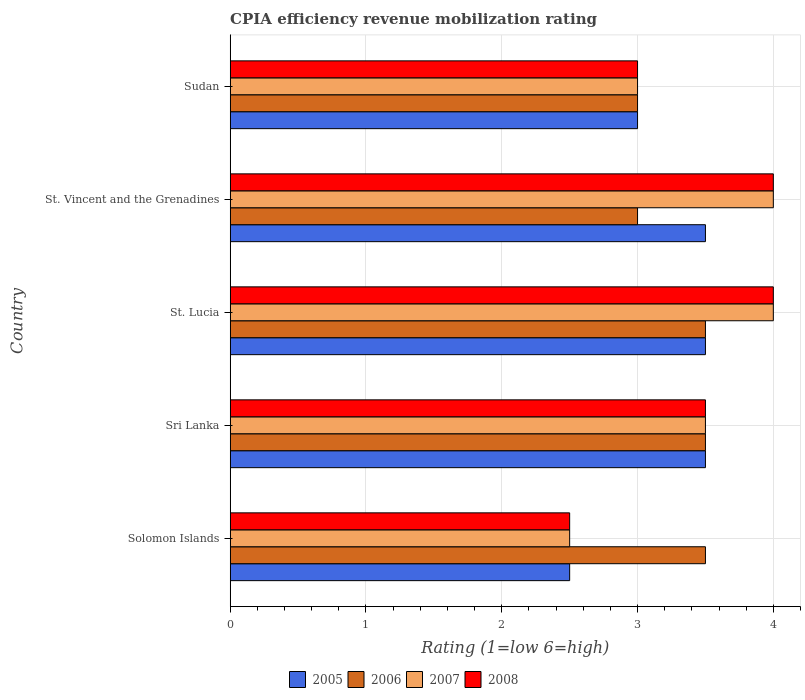How many groups of bars are there?
Provide a short and direct response. 5. Are the number of bars per tick equal to the number of legend labels?
Offer a terse response. Yes. Are the number of bars on each tick of the Y-axis equal?
Your response must be concise. Yes. How many bars are there on the 1st tick from the top?
Offer a terse response. 4. What is the label of the 3rd group of bars from the top?
Your answer should be compact. St. Lucia. In how many cases, is the number of bars for a given country not equal to the number of legend labels?
Keep it short and to the point. 0. Across all countries, what is the maximum CPIA rating in 2006?
Make the answer very short. 3.5. Across all countries, what is the minimum CPIA rating in 2007?
Offer a very short reply. 2.5. In which country was the CPIA rating in 2007 maximum?
Your answer should be compact. St. Lucia. In which country was the CPIA rating in 2007 minimum?
Your answer should be very brief. Solomon Islands. What is the total CPIA rating in 2007 in the graph?
Keep it short and to the point. 17. What is the difference between the CPIA rating in 2005 in Solomon Islands and that in St. Lucia?
Your answer should be compact. -1. What is the average CPIA rating in 2006 per country?
Your answer should be very brief. 3.3. What is the difference between the CPIA rating in 2007 and CPIA rating in 2006 in Solomon Islands?
Provide a succinct answer. -1. In how many countries, is the CPIA rating in 2008 greater than 1.2 ?
Ensure brevity in your answer.  5. What is the ratio of the CPIA rating in 2007 in St. Lucia to that in Sudan?
Give a very brief answer. 1.33. Is the difference between the CPIA rating in 2007 in Sri Lanka and St. Lucia greater than the difference between the CPIA rating in 2006 in Sri Lanka and St. Lucia?
Keep it short and to the point. No. What does the 1st bar from the top in Sri Lanka represents?
Offer a very short reply. 2008. Does the graph contain any zero values?
Give a very brief answer. No. How are the legend labels stacked?
Provide a short and direct response. Horizontal. What is the title of the graph?
Give a very brief answer. CPIA efficiency revenue mobilization rating. What is the label or title of the Y-axis?
Ensure brevity in your answer.  Country. What is the Rating (1=low 6=high) of 2005 in Solomon Islands?
Provide a succinct answer. 2.5. What is the Rating (1=low 6=high) of 2007 in Solomon Islands?
Make the answer very short. 2.5. What is the Rating (1=low 6=high) of 2005 in Sri Lanka?
Ensure brevity in your answer.  3.5. What is the Rating (1=low 6=high) of 2007 in Sri Lanka?
Offer a very short reply. 3.5. What is the Rating (1=low 6=high) of 2008 in Sri Lanka?
Ensure brevity in your answer.  3.5. What is the Rating (1=low 6=high) in 2005 in St. Vincent and the Grenadines?
Offer a terse response. 3.5. What is the Rating (1=low 6=high) of 2006 in St. Vincent and the Grenadines?
Offer a terse response. 3. What is the Rating (1=low 6=high) of 2007 in St. Vincent and the Grenadines?
Make the answer very short. 4. What is the Rating (1=low 6=high) of 2007 in Sudan?
Offer a terse response. 3. What is the Rating (1=low 6=high) in 2008 in Sudan?
Offer a terse response. 3. Across all countries, what is the maximum Rating (1=low 6=high) in 2007?
Give a very brief answer. 4. Across all countries, what is the maximum Rating (1=low 6=high) of 2008?
Ensure brevity in your answer.  4. Across all countries, what is the minimum Rating (1=low 6=high) in 2006?
Keep it short and to the point. 3. What is the total Rating (1=low 6=high) of 2006 in the graph?
Offer a terse response. 16.5. What is the difference between the Rating (1=low 6=high) of 2006 in Solomon Islands and that in Sri Lanka?
Your answer should be very brief. 0. What is the difference between the Rating (1=low 6=high) in 2008 in Solomon Islands and that in Sri Lanka?
Give a very brief answer. -1. What is the difference between the Rating (1=low 6=high) of 2007 in Solomon Islands and that in St. Lucia?
Offer a terse response. -1.5. What is the difference between the Rating (1=low 6=high) of 2005 in Solomon Islands and that in St. Vincent and the Grenadines?
Offer a terse response. -1. What is the difference between the Rating (1=low 6=high) of 2006 in Solomon Islands and that in St. Vincent and the Grenadines?
Offer a terse response. 0.5. What is the difference between the Rating (1=low 6=high) in 2007 in Solomon Islands and that in St. Vincent and the Grenadines?
Your answer should be compact. -1.5. What is the difference between the Rating (1=low 6=high) of 2005 in Solomon Islands and that in Sudan?
Provide a short and direct response. -0.5. What is the difference between the Rating (1=low 6=high) in 2007 in Solomon Islands and that in Sudan?
Your response must be concise. -0.5. What is the difference between the Rating (1=low 6=high) in 2005 in Sri Lanka and that in St. Lucia?
Provide a succinct answer. 0. What is the difference between the Rating (1=low 6=high) in 2006 in Sri Lanka and that in St. Lucia?
Your answer should be compact. 0. What is the difference between the Rating (1=low 6=high) in 2007 in Sri Lanka and that in St. Lucia?
Provide a succinct answer. -0.5. What is the difference between the Rating (1=low 6=high) of 2005 in Sri Lanka and that in St. Vincent and the Grenadines?
Provide a short and direct response. 0. What is the difference between the Rating (1=low 6=high) in 2007 in Sri Lanka and that in St. Vincent and the Grenadines?
Provide a short and direct response. -0.5. What is the difference between the Rating (1=low 6=high) in 2008 in Sri Lanka and that in St. Vincent and the Grenadines?
Offer a terse response. -0.5. What is the difference between the Rating (1=low 6=high) in 2005 in Sri Lanka and that in Sudan?
Your answer should be very brief. 0.5. What is the difference between the Rating (1=low 6=high) of 2006 in Sri Lanka and that in Sudan?
Provide a succinct answer. 0.5. What is the difference between the Rating (1=low 6=high) in 2007 in Sri Lanka and that in Sudan?
Provide a succinct answer. 0.5. What is the difference between the Rating (1=low 6=high) of 2008 in Sri Lanka and that in Sudan?
Your answer should be compact. 0.5. What is the difference between the Rating (1=low 6=high) in 2005 in St. Lucia and that in St. Vincent and the Grenadines?
Your response must be concise. 0. What is the difference between the Rating (1=low 6=high) of 2008 in St. Lucia and that in St. Vincent and the Grenadines?
Provide a short and direct response. 0. What is the difference between the Rating (1=low 6=high) in 2005 in St. Vincent and the Grenadines and that in Sudan?
Offer a very short reply. 0.5. What is the difference between the Rating (1=low 6=high) of 2006 in St. Vincent and the Grenadines and that in Sudan?
Provide a succinct answer. 0. What is the difference between the Rating (1=low 6=high) in 2005 in Solomon Islands and the Rating (1=low 6=high) in 2006 in Sri Lanka?
Give a very brief answer. -1. What is the difference between the Rating (1=low 6=high) of 2006 in Solomon Islands and the Rating (1=low 6=high) of 2007 in Sri Lanka?
Your response must be concise. 0. What is the difference between the Rating (1=low 6=high) of 2007 in Solomon Islands and the Rating (1=low 6=high) of 2008 in Sri Lanka?
Your answer should be compact. -1. What is the difference between the Rating (1=low 6=high) of 2005 in Solomon Islands and the Rating (1=low 6=high) of 2006 in St. Lucia?
Provide a succinct answer. -1. What is the difference between the Rating (1=low 6=high) of 2005 in Solomon Islands and the Rating (1=low 6=high) of 2007 in St. Lucia?
Offer a very short reply. -1.5. What is the difference between the Rating (1=low 6=high) in 2005 in Solomon Islands and the Rating (1=low 6=high) in 2008 in St. Lucia?
Your answer should be compact. -1.5. What is the difference between the Rating (1=low 6=high) in 2006 in Solomon Islands and the Rating (1=low 6=high) in 2007 in St. Vincent and the Grenadines?
Provide a succinct answer. -0.5. What is the difference between the Rating (1=low 6=high) of 2006 in Solomon Islands and the Rating (1=low 6=high) of 2008 in St. Vincent and the Grenadines?
Your answer should be very brief. -0.5. What is the difference between the Rating (1=low 6=high) in 2006 in Sri Lanka and the Rating (1=low 6=high) in 2008 in St. Lucia?
Your answer should be very brief. -0.5. What is the difference between the Rating (1=low 6=high) of 2005 in Sri Lanka and the Rating (1=low 6=high) of 2008 in St. Vincent and the Grenadines?
Give a very brief answer. -0.5. What is the difference between the Rating (1=low 6=high) in 2006 in Sri Lanka and the Rating (1=low 6=high) in 2007 in Sudan?
Offer a terse response. 0.5. What is the difference between the Rating (1=low 6=high) in 2006 in Sri Lanka and the Rating (1=low 6=high) in 2008 in Sudan?
Provide a succinct answer. 0.5. What is the difference between the Rating (1=low 6=high) in 2007 in Sri Lanka and the Rating (1=low 6=high) in 2008 in Sudan?
Your answer should be very brief. 0.5. What is the difference between the Rating (1=low 6=high) in 2005 in St. Lucia and the Rating (1=low 6=high) in 2006 in St. Vincent and the Grenadines?
Give a very brief answer. 0.5. What is the difference between the Rating (1=low 6=high) of 2005 in St. Lucia and the Rating (1=low 6=high) of 2007 in St. Vincent and the Grenadines?
Provide a succinct answer. -0.5. What is the difference between the Rating (1=low 6=high) in 2005 in St. Lucia and the Rating (1=low 6=high) in 2008 in St. Vincent and the Grenadines?
Your answer should be compact. -0.5. What is the difference between the Rating (1=low 6=high) in 2007 in St. Lucia and the Rating (1=low 6=high) in 2008 in St. Vincent and the Grenadines?
Provide a succinct answer. 0. What is the difference between the Rating (1=low 6=high) in 2005 in St. Lucia and the Rating (1=low 6=high) in 2007 in Sudan?
Your answer should be compact. 0.5. What is the difference between the Rating (1=low 6=high) of 2005 in St. Lucia and the Rating (1=low 6=high) of 2008 in Sudan?
Give a very brief answer. 0.5. What is the difference between the Rating (1=low 6=high) in 2006 in St. Lucia and the Rating (1=low 6=high) in 2007 in Sudan?
Your answer should be very brief. 0.5. What is the difference between the Rating (1=low 6=high) of 2006 in St. Lucia and the Rating (1=low 6=high) of 2008 in Sudan?
Offer a very short reply. 0.5. What is the difference between the Rating (1=low 6=high) in 2005 in St. Vincent and the Grenadines and the Rating (1=low 6=high) in 2007 in Sudan?
Make the answer very short. 0.5. What is the difference between the Rating (1=low 6=high) in 2005 in St. Vincent and the Grenadines and the Rating (1=low 6=high) in 2008 in Sudan?
Make the answer very short. 0.5. What is the difference between the Rating (1=low 6=high) in 2006 in St. Vincent and the Grenadines and the Rating (1=low 6=high) in 2007 in Sudan?
Make the answer very short. 0. What is the average Rating (1=low 6=high) in 2005 per country?
Provide a succinct answer. 3.2. What is the average Rating (1=low 6=high) in 2007 per country?
Your answer should be very brief. 3.4. What is the difference between the Rating (1=low 6=high) in 2005 and Rating (1=low 6=high) in 2006 in Solomon Islands?
Provide a short and direct response. -1. What is the difference between the Rating (1=low 6=high) in 2005 and Rating (1=low 6=high) in 2007 in Solomon Islands?
Provide a succinct answer. 0. What is the difference between the Rating (1=low 6=high) in 2006 and Rating (1=low 6=high) in 2007 in Solomon Islands?
Offer a terse response. 1. What is the difference between the Rating (1=low 6=high) of 2005 and Rating (1=low 6=high) of 2006 in Sri Lanka?
Offer a very short reply. 0. What is the difference between the Rating (1=low 6=high) in 2006 and Rating (1=low 6=high) in 2008 in Sri Lanka?
Make the answer very short. 0. What is the difference between the Rating (1=low 6=high) of 2005 and Rating (1=low 6=high) of 2006 in St. Lucia?
Provide a succinct answer. 0. What is the difference between the Rating (1=low 6=high) in 2005 and Rating (1=low 6=high) in 2007 in St. Lucia?
Give a very brief answer. -0.5. What is the difference between the Rating (1=low 6=high) of 2005 and Rating (1=low 6=high) of 2008 in St. Lucia?
Give a very brief answer. -0.5. What is the difference between the Rating (1=low 6=high) of 2006 and Rating (1=low 6=high) of 2007 in St. Lucia?
Make the answer very short. -0.5. What is the difference between the Rating (1=low 6=high) in 2006 and Rating (1=low 6=high) in 2008 in St. Lucia?
Offer a terse response. -0.5. What is the difference between the Rating (1=low 6=high) in 2005 and Rating (1=low 6=high) in 2007 in St. Vincent and the Grenadines?
Your response must be concise. -0.5. What is the difference between the Rating (1=low 6=high) of 2006 and Rating (1=low 6=high) of 2007 in St. Vincent and the Grenadines?
Your answer should be very brief. -1. What is the difference between the Rating (1=low 6=high) in 2005 and Rating (1=low 6=high) in 2008 in Sudan?
Your answer should be compact. 0. What is the difference between the Rating (1=low 6=high) of 2006 and Rating (1=low 6=high) of 2008 in Sudan?
Your response must be concise. 0. What is the ratio of the Rating (1=low 6=high) in 2005 in Solomon Islands to that in Sri Lanka?
Keep it short and to the point. 0.71. What is the ratio of the Rating (1=low 6=high) of 2005 in Solomon Islands to that in St. Lucia?
Provide a succinct answer. 0.71. What is the ratio of the Rating (1=low 6=high) of 2007 in Solomon Islands to that in St. Lucia?
Offer a terse response. 0.62. What is the ratio of the Rating (1=low 6=high) of 2008 in Solomon Islands to that in St. Lucia?
Offer a terse response. 0.62. What is the ratio of the Rating (1=low 6=high) of 2005 in Solomon Islands to that in St. Vincent and the Grenadines?
Your response must be concise. 0.71. What is the ratio of the Rating (1=low 6=high) of 2006 in Solomon Islands to that in St. Vincent and the Grenadines?
Ensure brevity in your answer.  1.17. What is the ratio of the Rating (1=low 6=high) of 2007 in Solomon Islands to that in St. Vincent and the Grenadines?
Your response must be concise. 0.62. What is the ratio of the Rating (1=low 6=high) of 2008 in Solomon Islands to that in St. Vincent and the Grenadines?
Provide a succinct answer. 0.62. What is the ratio of the Rating (1=low 6=high) in 2005 in Solomon Islands to that in Sudan?
Your response must be concise. 0.83. What is the ratio of the Rating (1=low 6=high) in 2008 in Solomon Islands to that in Sudan?
Offer a very short reply. 0.83. What is the ratio of the Rating (1=low 6=high) of 2005 in Sri Lanka to that in St. Lucia?
Offer a very short reply. 1. What is the ratio of the Rating (1=low 6=high) of 2006 in Sri Lanka to that in St. Lucia?
Offer a terse response. 1. What is the ratio of the Rating (1=low 6=high) of 2006 in Sri Lanka to that in St. Vincent and the Grenadines?
Keep it short and to the point. 1.17. What is the ratio of the Rating (1=low 6=high) of 2007 in Sri Lanka to that in St. Vincent and the Grenadines?
Your answer should be compact. 0.88. What is the ratio of the Rating (1=low 6=high) in 2008 in Sri Lanka to that in St. Vincent and the Grenadines?
Keep it short and to the point. 0.88. What is the ratio of the Rating (1=low 6=high) in 2006 in Sri Lanka to that in Sudan?
Keep it short and to the point. 1.17. What is the ratio of the Rating (1=low 6=high) of 2007 in Sri Lanka to that in Sudan?
Give a very brief answer. 1.17. What is the ratio of the Rating (1=low 6=high) in 2005 in St. Lucia to that in St. Vincent and the Grenadines?
Make the answer very short. 1. What is the ratio of the Rating (1=low 6=high) of 2006 in St. Lucia to that in St. Vincent and the Grenadines?
Provide a succinct answer. 1.17. What is the ratio of the Rating (1=low 6=high) in 2005 in St. Vincent and the Grenadines to that in Sudan?
Offer a terse response. 1.17. What is the ratio of the Rating (1=low 6=high) in 2006 in St. Vincent and the Grenadines to that in Sudan?
Provide a short and direct response. 1. What is the ratio of the Rating (1=low 6=high) in 2007 in St. Vincent and the Grenadines to that in Sudan?
Keep it short and to the point. 1.33. What is the difference between the highest and the second highest Rating (1=low 6=high) of 2005?
Provide a short and direct response. 0. What is the difference between the highest and the lowest Rating (1=low 6=high) in 2005?
Ensure brevity in your answer.  1. What is the difference between the highest and the lowest Rating (1=low 6=high) in 2007?
Your response must be concise. 1.5. 